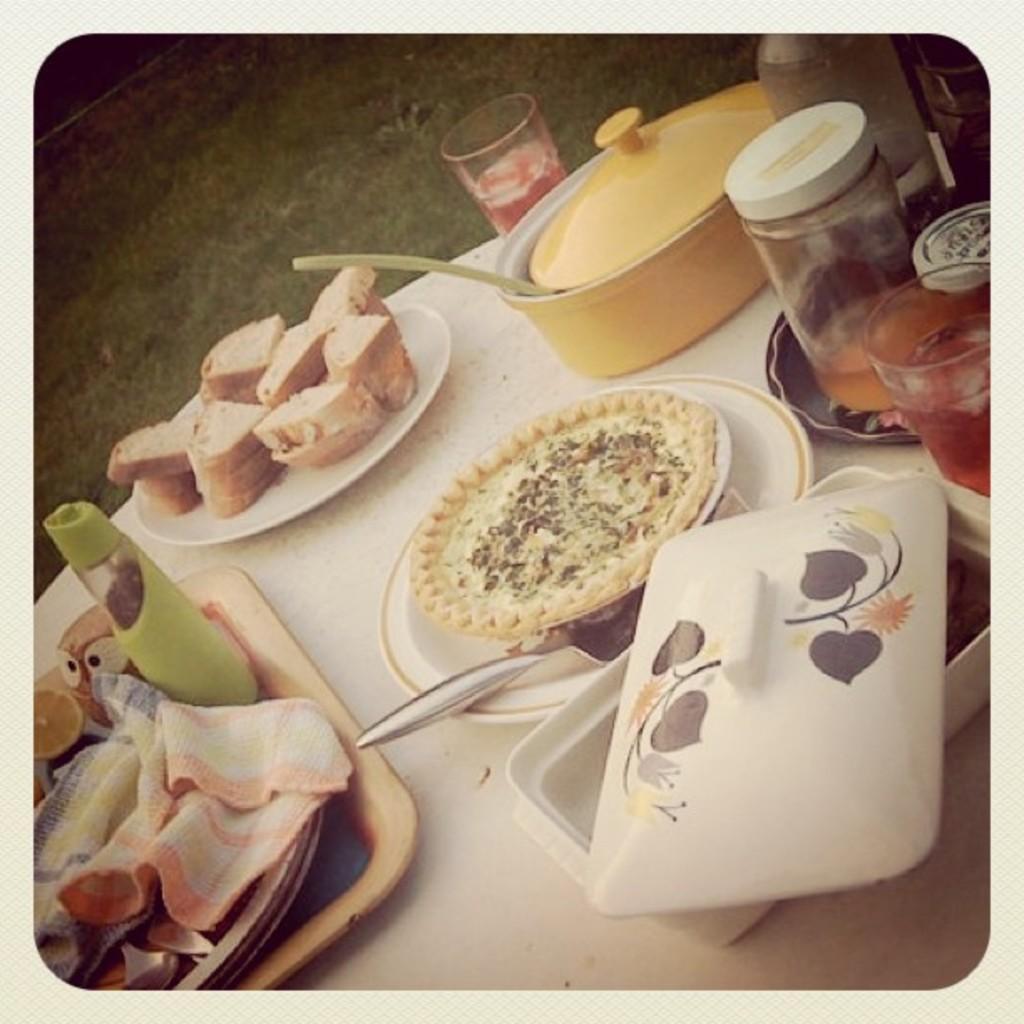Can you describe this image briefly? In this image we can see plates with food items, bowls covered with lids and there are spoons, a tray with a cloth and few objects, a jar bottle and glasses with dink and few other objects on the table and grass in the background. 